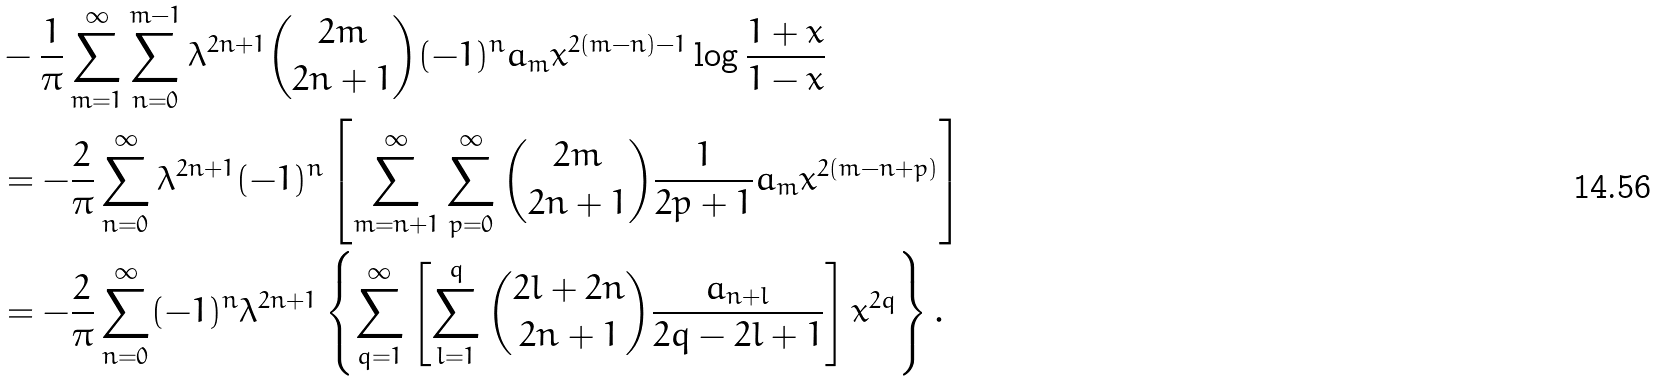Convert formula to latex. <formula><loc_0><loc_0><loc_500><loc_500>& - \frac { 1 } { \pi } \sum _ { m = 1 } ^ { \infty } \sum _ { n = 0 } ^ { m - 1 } \lambda ^ { 2 n + 1 } \binom { 2 m } { 2 n + 1 } ( - 1 ) ^ { n } a _ { m } x ^ { 2 ( m - n ) - 1 } \log \frac { 1 + x } { 1 - x } \\ & = - \frac { 2 } { \pi } \sum _ { n = 0 } ^ { \infty } \lambda ^ { 2 n + 1 } ( - 1 ) ^ { n } \left [ \sum _ { m = n + 1 } ^ { \infty } \sum _ { p = 0 } ^ { \infty } \binom { 2 m } { 2 n + 1 } \frac { 1 } { 2 p + 1 } a _ { m } x ^ { 2 ( m - n + p ) } \right ] \\ & = - \frac { 2 } { \pi } \sum _ { n = 0 } ^ { \infty } ( - 1 ) ^ { n } \lambda ^ { 2 n + 1 } \left \{ \sum _ { q = 1 } ^ { \infty } \left [ \sum _ { l = 1 } ^ { q } \binom { 2 l + 2 n } { 2 n + 1 } \frac { a _ { n + l } } { 2 q - 2 l + 1 } \right ] x ^ { 2 q } \right \} .</formula> 